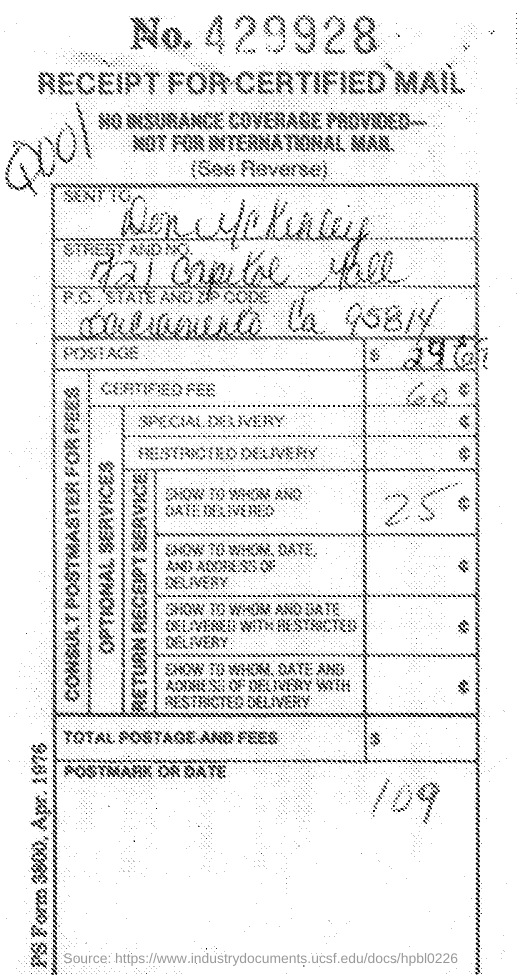What is the receipt number ?
Your answer should be very brief. 429928. What receipt is this?
Make the answer very short. Receipt for certified mail. How much is certified fee?
Make the answer very short. 60. 